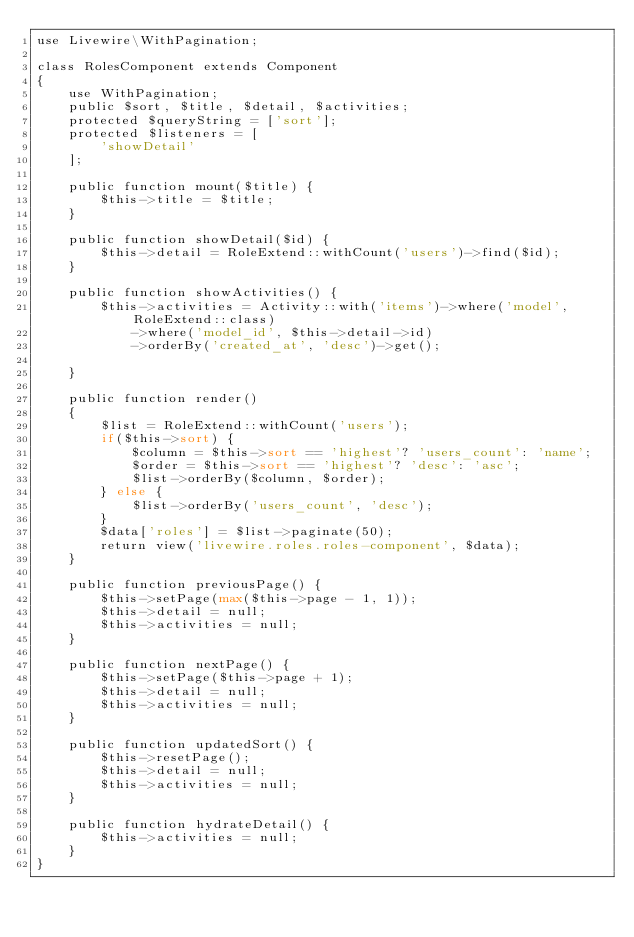Convert code to text. <code><loc_0><loc_0><loc_500><loc_500><_PHP_>use Livewire\WithPagination;

class RolesComponent extends Component
{
    use WithPagination;
    public $sort, $title, $detail, $activities;
    protected $queryString = ['sort'];
    protected $listeners = [
        'showDetail'
    ];

    public function mount($title) {
        $this->title = $title;
    }

    public function showDetail($id) {
        $this->detail = RoleExtend::withCount('users')->find($id);
    }

    public function showActivities() {
        $this->activities = Activity::with('items')->where('model', RoleExtend::class)
            ->where('model_id', $this->detail->id)
            ->orderBy('created_at', 'desc')->get();

    }

    public function render()
    {
        $list = RoleExtend::withCount('users');
        if($this->sort) {
            $column = $this->sort == 'highest'? 'users_count': 'name';
            $order = $this->sort == 'highest'? 'desc': 'asc';
            $list->orderBy($column, $order);
        } else {
            $list->orderBy('users_count', 'desc');
        }
        $data['roles'] = $list->paginate(50);
        return view('livewire.roles.roles-component', $data);
    }

    public function previousPage() {
        $this->setPage(max($this->page - 1, 1));
        $this->detail = null;
        $this->activities = null;
    }

    public function nextPage() {
        $this->setPage($this->page + 1);
        $this->detail = null;
        $this->activities = null;
    }

    public function updatedSort() {
        $this->resetPage();
        $this->detail = null;
        $this->activities = null;
    }

    public function hydrateDetail() {
        $this->activities = null;
    }
}
</code> 